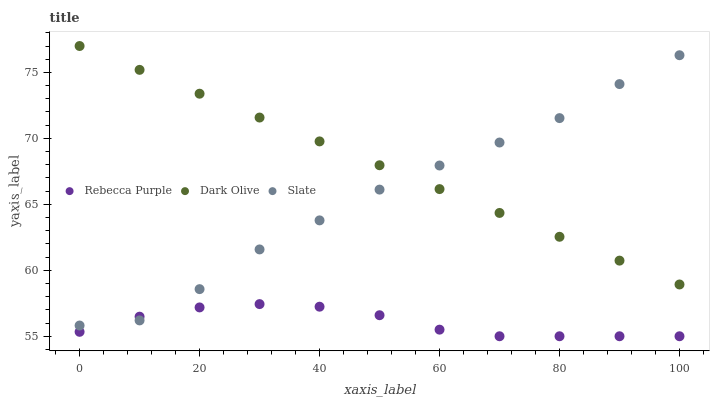Does Rebecca Purple have the minimum area under the curve?
Answer yes or no. Yes. Does Dark Olive have the maximum area under the curve?
Answer yes or no. Yes. Does Dark Olive have the minimum area under the curve?
Answer yes or no. No. Does Rebecca Purple have the maximum area under the curve?
Answer yes or no. No. Is Dark Olive the smoothest?
Answer yes or no. Yes. Is Slate the roughest?
Answer yes or no. Yes. Is Rebecca Purple the smoothest?
Answer yes or no. No. Is Rebecca Purple the roughest?
Answer yes or no. No. Does Rebecca Purple have the lowest value?
Answer yes or no. Yes. Does Dark Olive have the lowest value?
Answer yes or no. No. Does Dark Olive have the highest value?
Answer yes or no. Yes. Does Rebecca Purple have the highest value?
Answer yes or no. No. Is Rebecca Purple less than Dark Olive?
Answer yes or no. Yes. Is Dark Olive greater than Rebecca Purple?
Answer yes or no. Yes. Does Dark Olive intersect Slate?
Answer yes or no. Yes. Is Dark Olive less than Slate?
Answer yes or no. No. Is Dark Olive greater than Slate?
Answer yes or no. No. Does Rebecca Purple intersect Dark Olive?
Answer yes or no. No. 